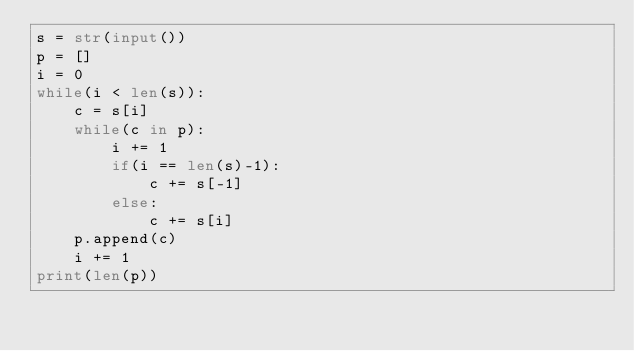<code> <loc_0><loc_0><loc_500><loc_500><_Python_>s = str(input())
p = []
i = 0
while(i < len(s)):
    c = s[i]
    while(c in p):
        i += 1
        if(i == len(s)-1):
            c += s[-1]
        else:
            c += s[i]
    p.append(c)
    i += 1
print(len(p))</code> 